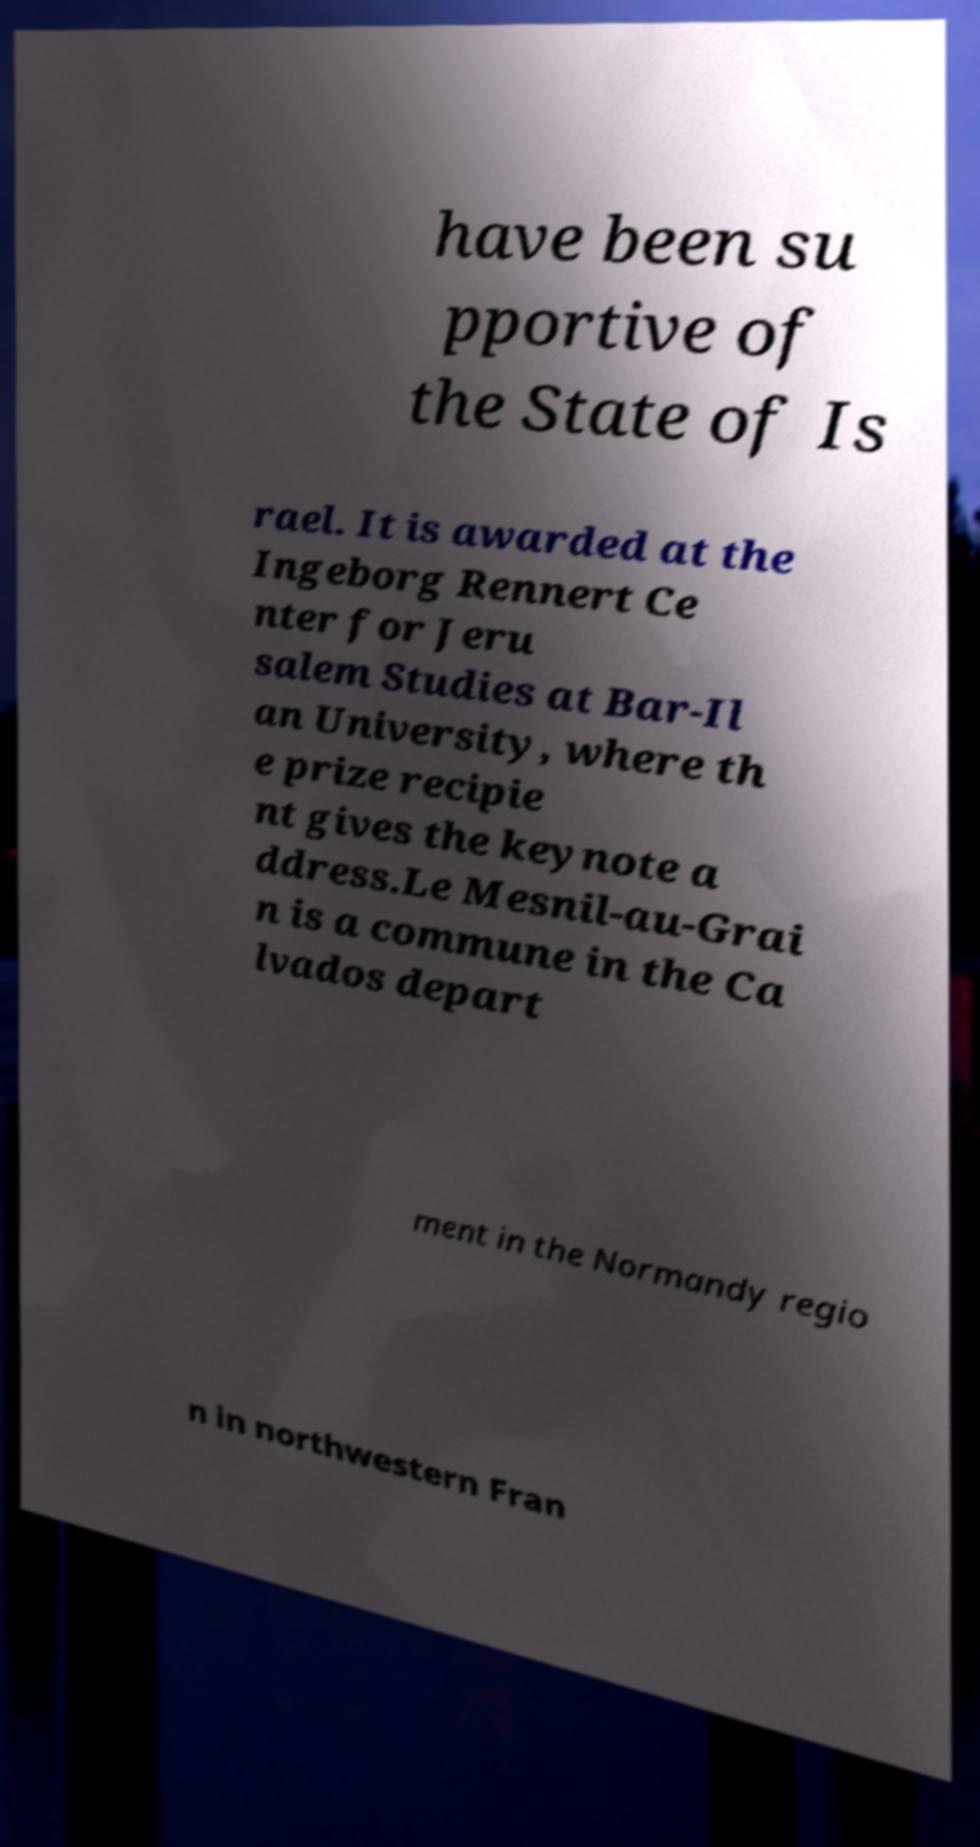For documentation purposes, I need the text within this image transcribed. Could you provide that? have been su pportive of the State of Is rael. It is awarded at the Ingeborg Rennert Ce nter for Jeru salem Studies at Bar-Il an University, where th e prize recipie nt gives the keynote a ddress.Le Mesnil-au-Grai n is a commune in the Ca lvados depart ment in the Normandy regio n in northwestern Fran 